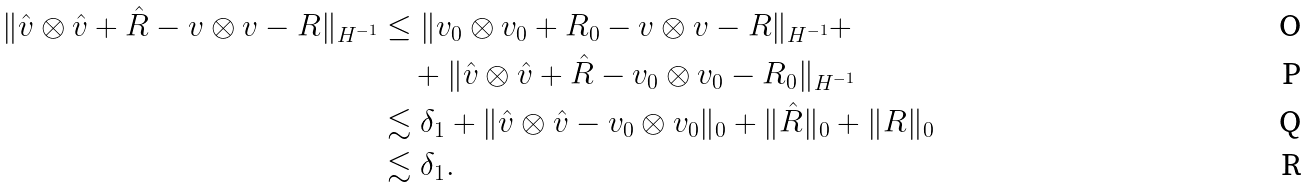<formula> <loc_0><loc_0><loc_500><loc_500>\| \hat { v } \otimes \hat { v } + \hat { R } - v \otimes v - R \| _ { H ^ { - 1 } } & \leq \| v _ { 0 } \otimes v _ { 0 } + R _ { 0 } - v \otimes v - R \| _ { H ^ { - 1 } } + \\ & \quad + \| \hat { v } \otimes \hat { v } + \hat { R } - v _ { 0 } \otimes v _ { 0 } - R _ { 0 } \| _ { H ^ { - 1 } } \\ & \lesssim \delta _ { 1 } + \| \hat { v } \otimes \hat { v } - v _ { 0 } \otimes v _ { 0 } \| _ { 0 } + \| \hat { R } \| _ { 0 } + \| R \| _ { 0 } \\ & \lesssim \delta _ { 1 } .</formula> 